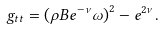Convert formula to latex. <formula><loc_0><loc_0><loc_500><loc_500>g _ { t t } = \left ( \rho B e ^ { - \nu } \omega \right ) ^ { 2 } - e ^ { 2 \nu } .</formula> 